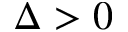<formula> <loc_0><loc_0><loc_500><loc_500>\Delta > 0</formula> 